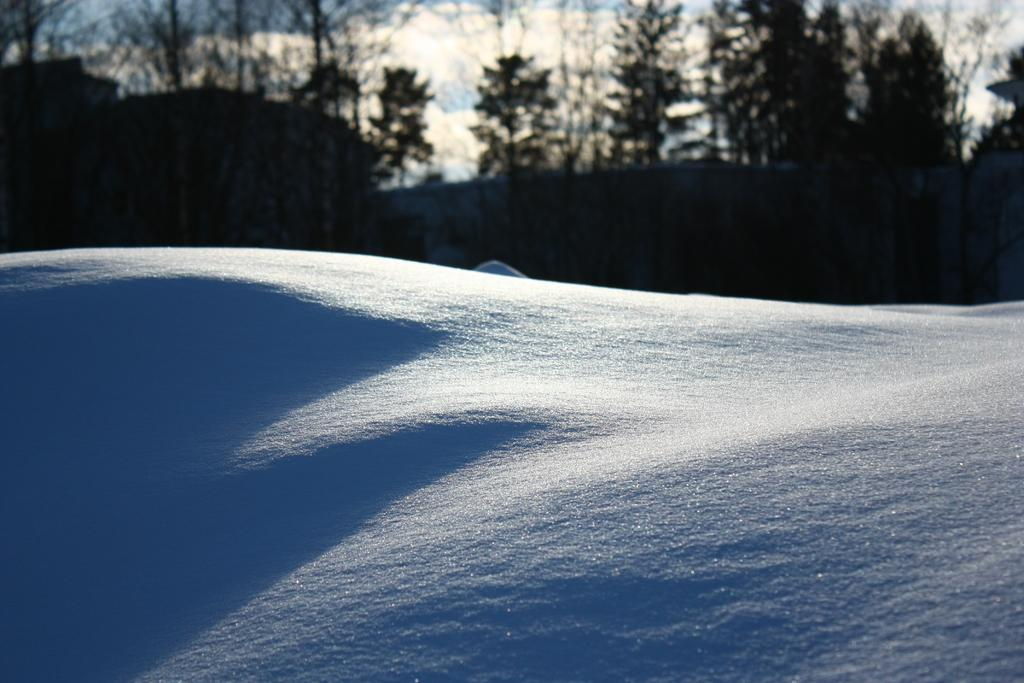What type of landscape is visible in the front of the image? There is a snowy landscape in the front of the image. What natural elements can be seen in the image? Trees are visible in the image. What part of the natural environment is visible in the image? The sky is visible in the image. What can be observed in the sky? Clouds are present in the sky. What type of cave can be seen in the snowy landscape of the image? There is no cave present in the image; it features a snowy landscape with trees and a visible sky. What sound does the giraffe make in the image? There is no giraffe present in the image, so it is not possible to determine the sound it might make. 